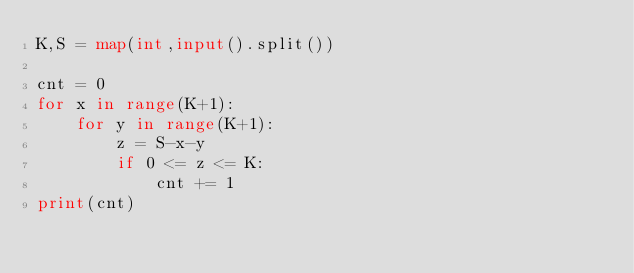Convert code to text. <code><loc_0><loc_0><loc_500><loc_500><_Python_>K,S = map(int,input().split())

cnt = 0
for x in range(K+1):
    for y in range(K+1):
        z = S-x-y
        if 0 <= z <= K:
            cnt += 1
print(cnt)</code> 